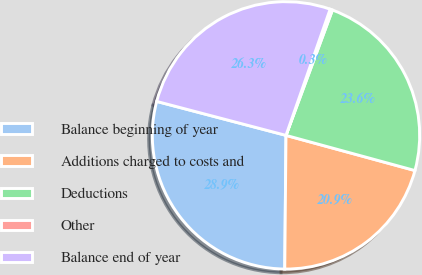Convert chart. <chart><loc_0><loc_0><loc_500><loc_500><pie_chart><fcel>Balance beginning of year<fcel>Additions charged to costs and<fcel>Deductions<fcel>Other<fcel>Balance end of year<nl><fcel>28.94%<fcel>20.91%<fcel>23.59%<fcel>0.29%<fcel>26.27%<nl></chart> 